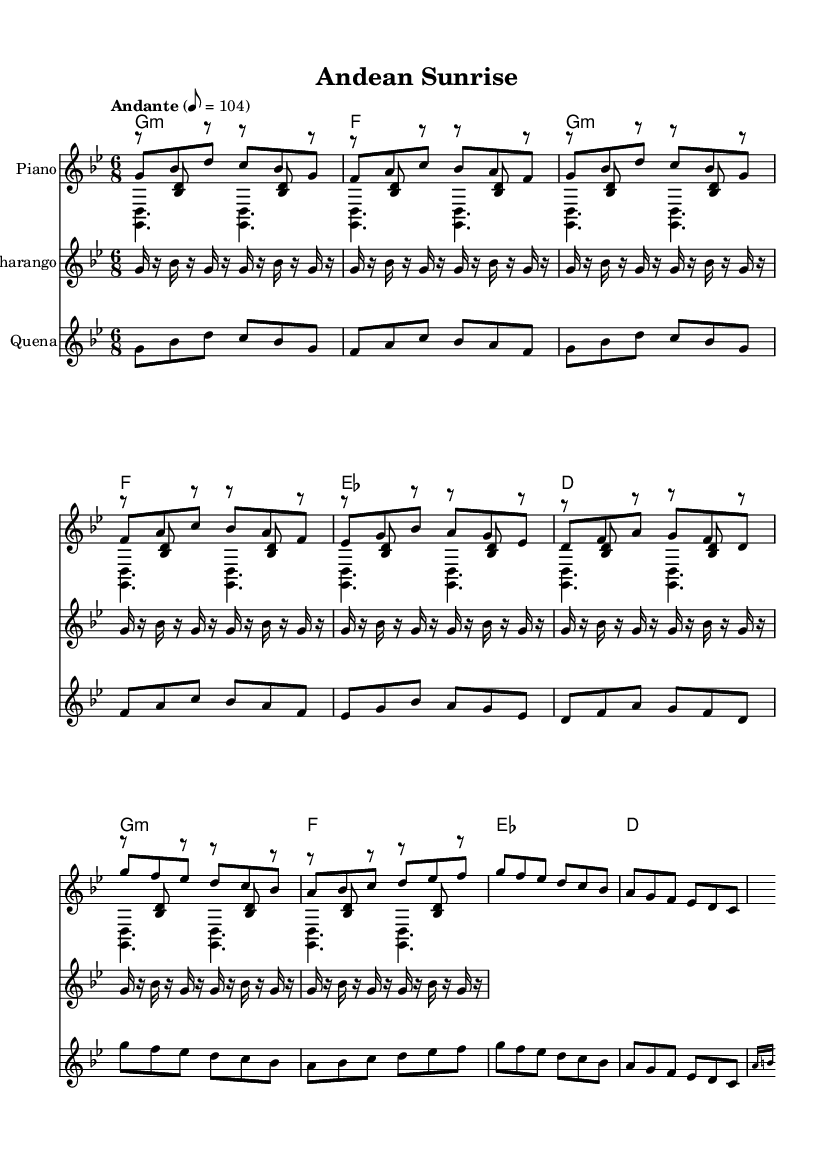What is the key signature of this music? The key signature is indicated at the beginning of the staff. In this case, it shows two flats, which signifies B flat and E flat as the flats in the scale. This identifies the key as G minor.
Answer: G minor What is the time signature of this piece? The time signature is also found at the beginning of the score, represented as a fraction. Here, it is noted as 6 over 8, meaning there are six eighth-note beats in each measure.
Answer: 6/8 What is the tempo marking of this piece? The tempo instruction is directly indicated in the score, mentioning "Andante" and specifying a metronome marking of 8 = 104. This indicates a moderate pace.
Answer: Andante How many measures are in the melody section? By counting the individual groupings of notes or bars, the melody consists of a total of 8 measures represented before the first repeat indication in the score.
Answer: 8 measures What instruments are featured in this arrangement? The arrangement explicitly lists four parts: Piano, Charango, and Quena, telling which instruments will play these melodic lines in the performance.
Answer: Piano, Charango, Quena Which section has a distinct rhythm pattern played by the Charango? The rhythm pattern for the Charango is specified in the score under its part, detailing its unique 16th-note rhythm. This pattern starts from the beginning and continues throughout the piece, differing from the melody.
Answer: Charango rhythm pattern What is the harmonic structure for the chorus section? The harmonic part for the chorus indicates a consistent support with the chords played in a steady manner. Looking at the chord symbols, the sequence for the chorus consists primarily of G minor, F major, E flat major, and D major chords.
Answer: G minor, F major, E flat major, D major 